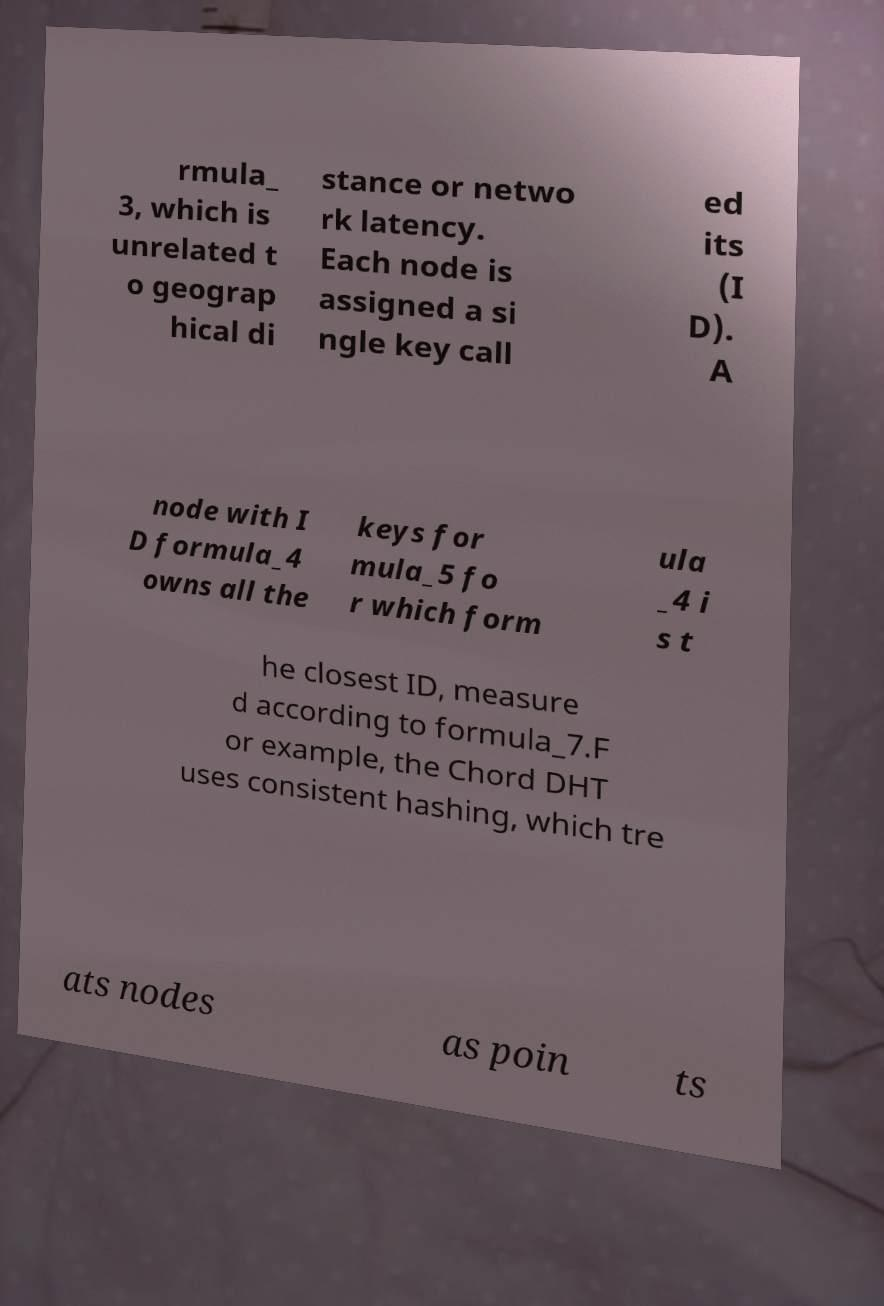Could you extract and type out the text from this image? rmula_ 3, which is unrelated t o geograp hical di stance or netwo rk latency. Each node is assigned a si ngle key call ed its (I D). A node with I D formula_4 owns all the keys for mula_5 fo r which form ula _4 i s t he closest ID, measure d according to formula_7.F or example, the Chord DHT uses consistent hashing, which tre ats nodes as poin ts 